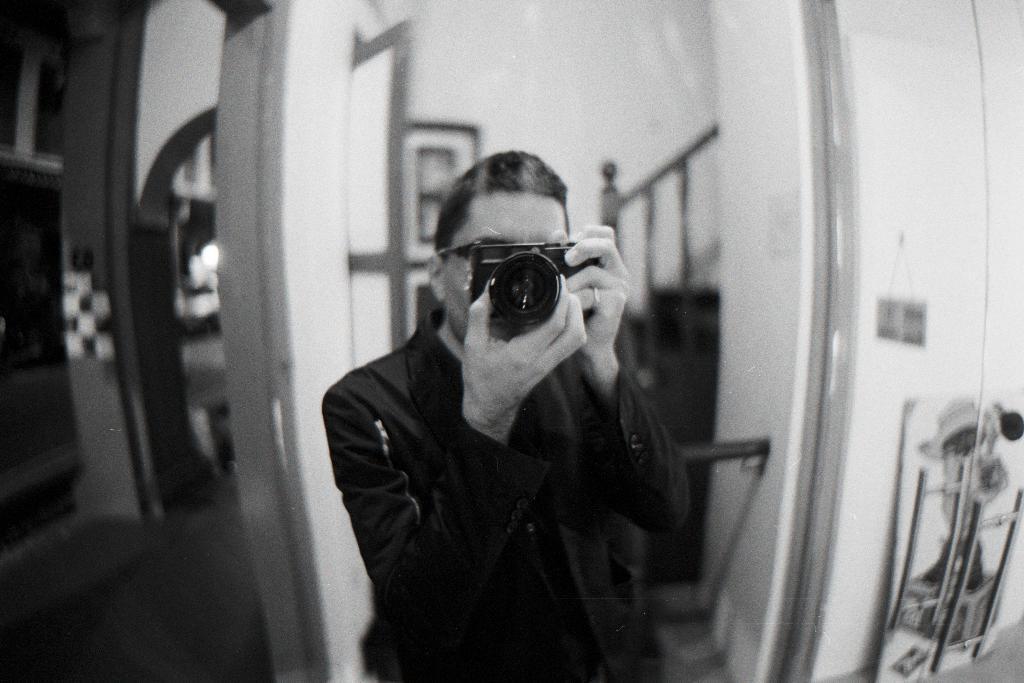How would you summarize this image in a sentence or two? This is a black and white picture. Here we can see a person who is holding a camera with his hands. In the background there is a wall and this is staircase. Here we can see a door and these are the frames. And this is pillar. 